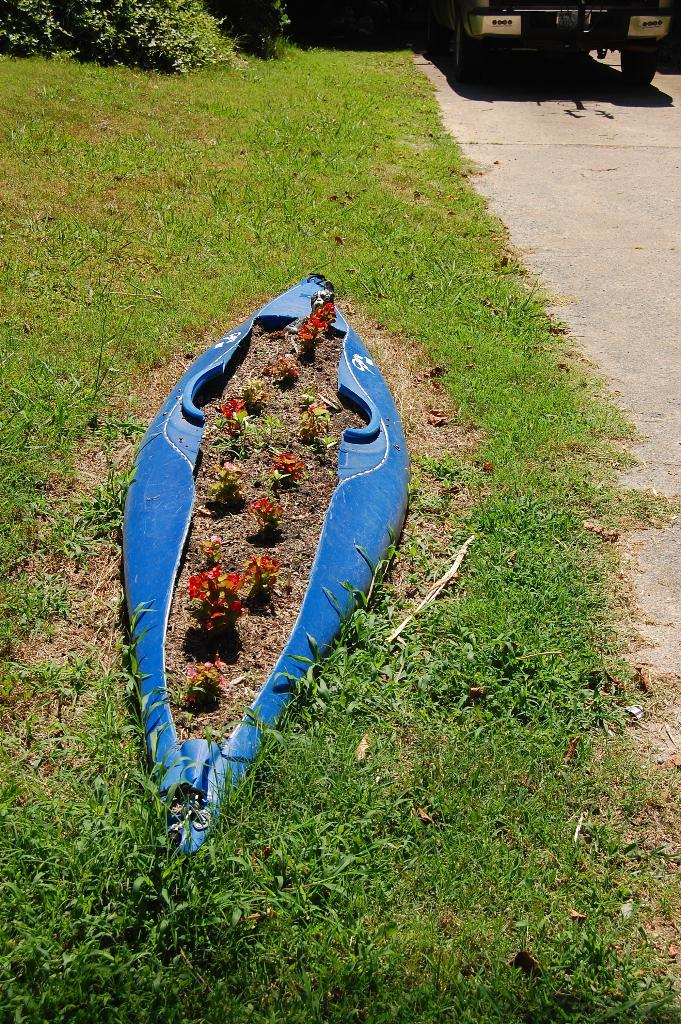What can be seen in the foreground of the image? In the foreground of the image, there are plants, grass, a road, and a blue color object. What is present at the top of the image? At the top of the image, there are plants, a vehicle, a road, and grass. Can you describe the plants in the image? The plants are present both in the foreground and at the top of the image. What type of road is visible in the image? The road is visible in both the foreground and at the top of the image. Can you tell me how many berries are on the receipt in the image? There is no berry or receipt present in the image. What is the level of fear expressed by the plants in the image? The plants in the image do not express fear, as they are inanimate objects. 